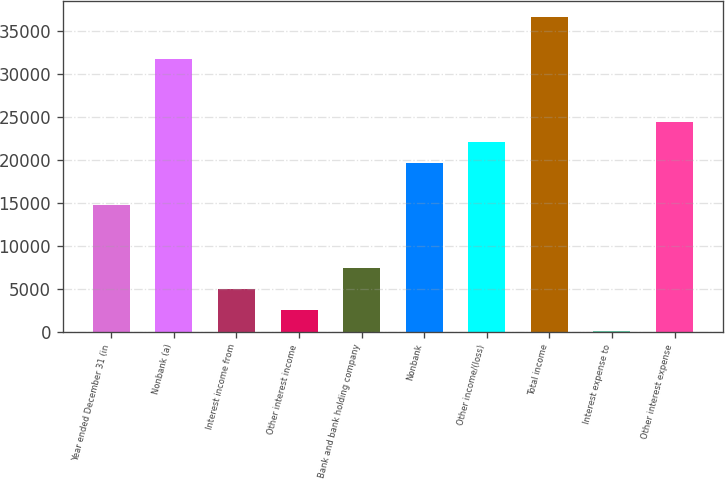Convert chart to OTSL. <chart><loc_0><loc_0><loc_500><loc_500><bar_chart><fcel>Year ended December 31 (in<fcel>Nonbank (a)<fcel>Interest income from<fcel>Other interest income<fcel>Bank and bank holding company<fcel>Nonbank<fcel>Other income/(loss)<fcel>Total income<fcel>Interest expense to<fcel>Other interest expense<nl><fcel>14704.4<fcel>31745.2<fcel>4966.8<fcel>2532.4<fcel>7401.2<fcel>19573.2<fcel>22007.6<fcel>36614<fcel>98<fcel>24442<nl></chart> 